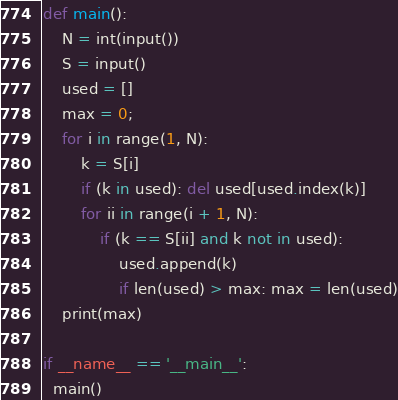<code> <loc_0><loc_0><loc_500><loc_500><_Python_>def main():
    N = int(input())
    S = input()
    used = []
    max = 0;
    for i in range(1, N):
        k = S[i]
        if (k in used): del used[used.index(k)]
        for ii in range(i + 1, N):
            if (k == S[ii] and k not in used):
                used.append(k)
                if len(used) > max: max = len(used)
    print(max)

if __name__ == '__main__':
  main()</code> 